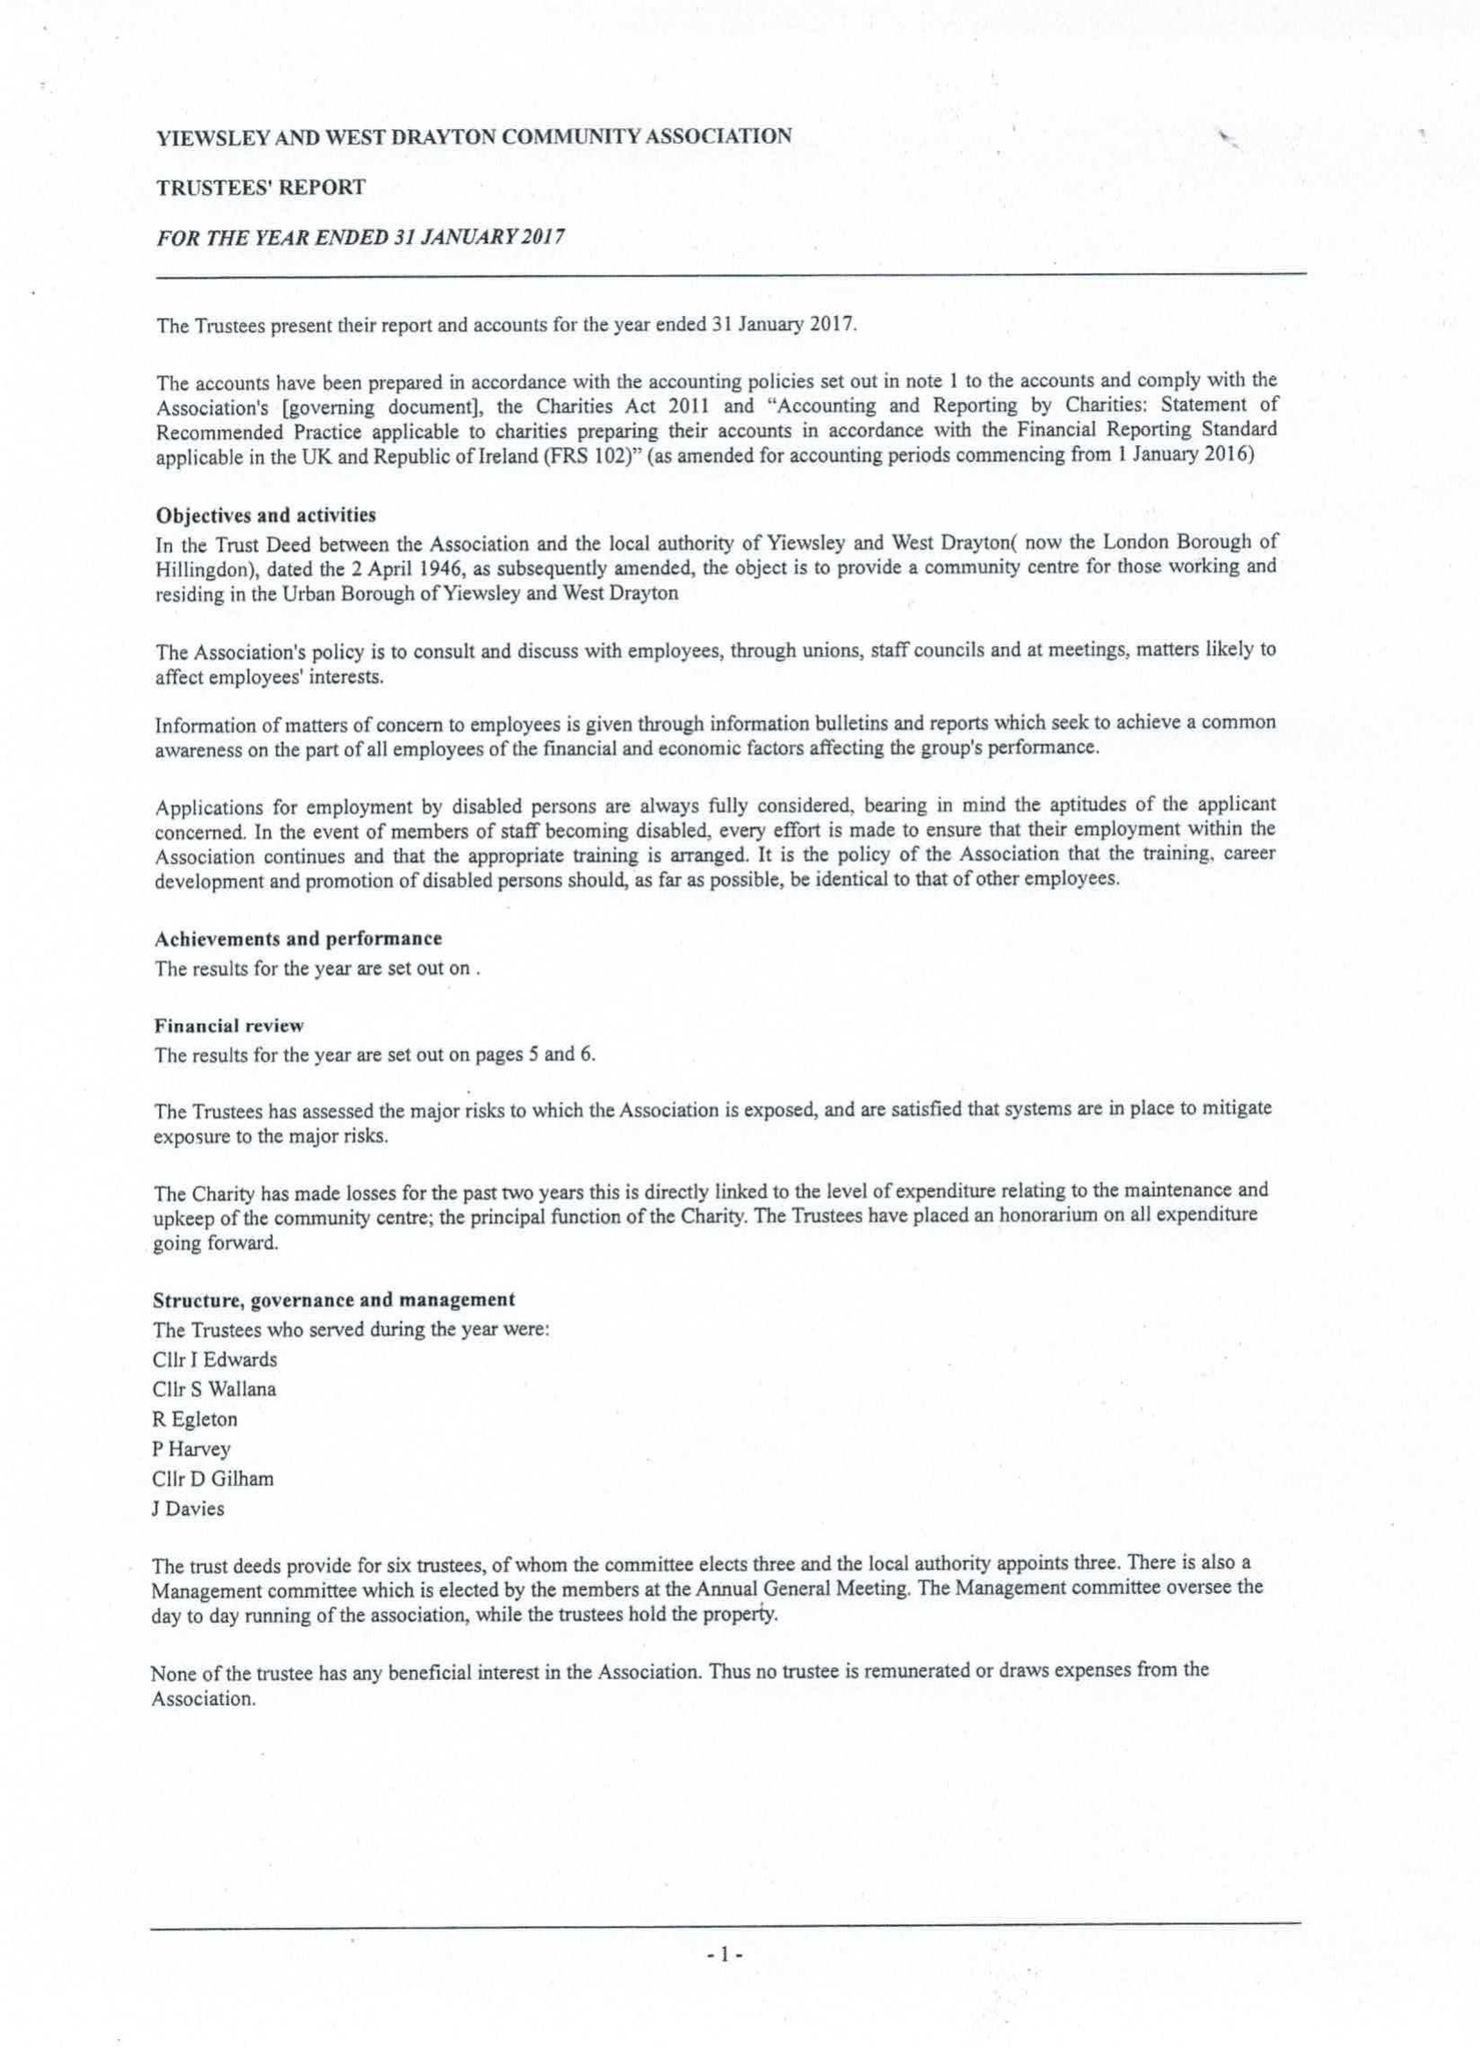What is the value for the charity_number?
Answer the question using a single word or phrase. 303087 